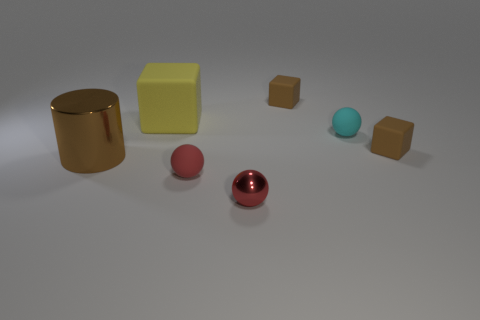What could be the possible purpose of arranging these objects in such a manner? This arrangement seems to be a deliberate composition designed to showcase the contrast and comparison between colors, materials, and shapes. The purpose might be educational, to help viewers distinguish between various textures and geometric forms, or it could be for aesthetic purposes, creating a visually pleasing balance between the elements. It may also serve as a scene in a graphic design or 3D modeling exercise, where lighting and shadow effects on different surfaces can be observed. 